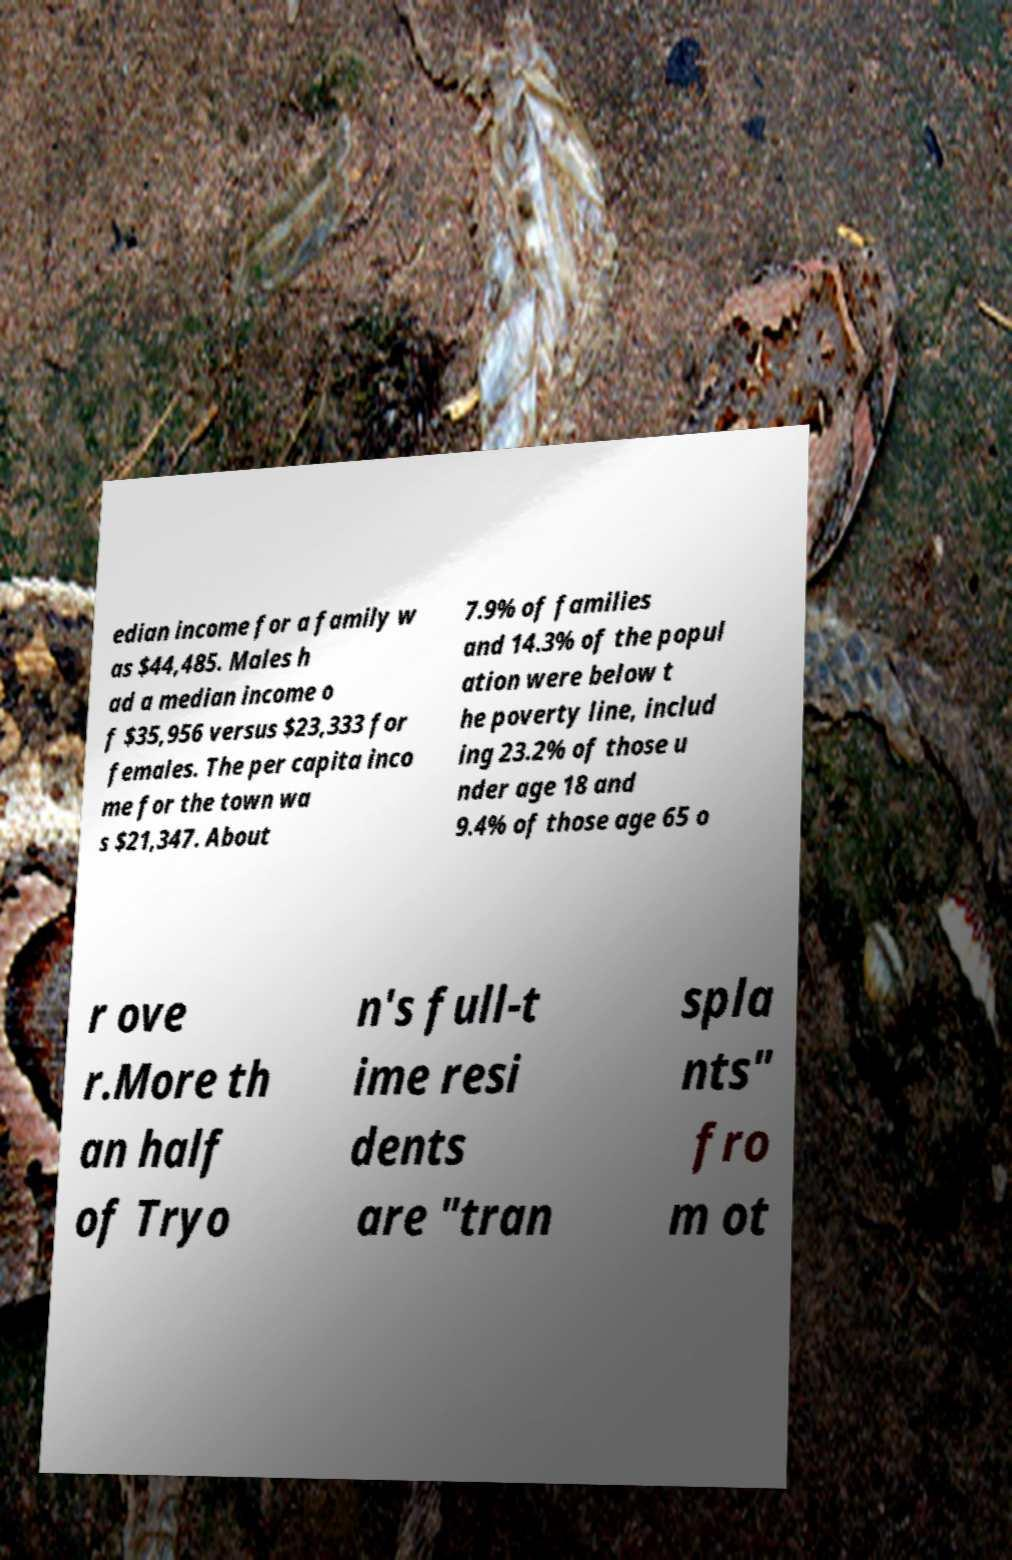There's text embedded in this image that I need extracted. Can you transcribe it verbatim? edian income for a family w as $44,485. Males h ad a median income o f $35,956 versus $23,333 for females. The per capita inco me for the town wa s $21,347. About 7.9% of families and 14.3% of the popul ation were below t he poverty line, includ ing 23.2% of those u nder age 18 and 9.4% of those age 65 o r ove r.More th an half of Tryo n's full-t ime resi dents are "tran spla nts" fro m ot 